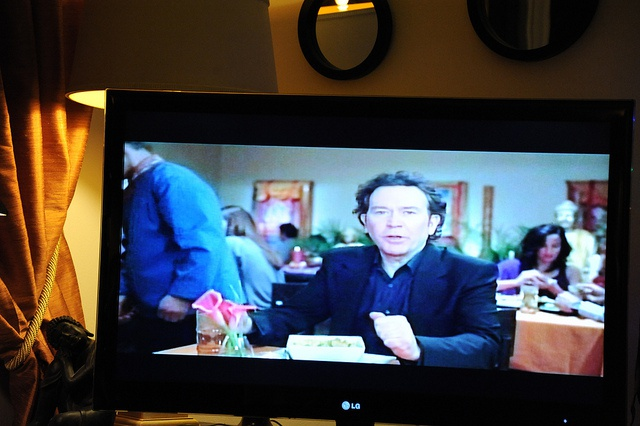Describe the objects in this image and their specific colors. I can see tv in black, navy, lightblue, and white tones, people in black, navy, lavender, and darkblue tones, people in black, darkblue, lightblue, and navy tones, dining table in black, white, lightblue, and darkgray tones, and dining table in black, salmon, and maroon tones in this image. 